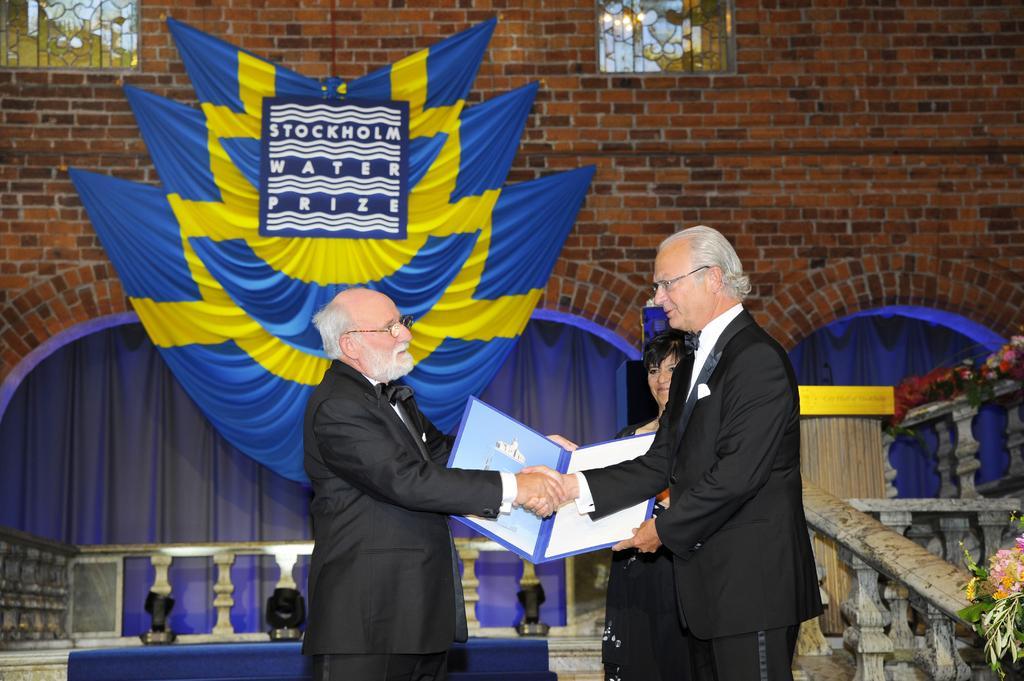How would you summarize this image in a sentence or two? In this image, we can see persons wearing clothes. There are two persons shaking hands and holding a file with their hands. There is a wall decorated with clothes. There are curtains in the middle of the image. There are windows on the wall. 